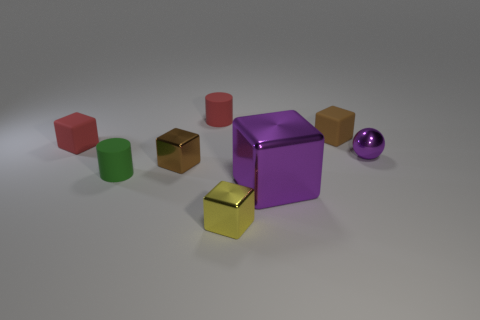How many objects are tiny green rubber cylinders or purple shiny blocks?
Keep it short and to the point. 2. There is a red cylinder; is it the same size as the metallic thing that is on the left side of the yellow cube?
Offer a very short reply. Yes. There is a matte cylinder that is in front of the brown thing that is behind the purple thing behind the large purple metal thing; what size is it?
Provide a succinct answer. Small. Are there any tiny brown matte cylinders?
Offer a very short reply. No. What number of balls have the same color as the big shiny object?
Keep it short and to the point. 1. What number of objects are tiny yellow metallic things in front of the tiny green thing or small cylinders in front of the purple metallic sphere?
Provide a succinct answer. 2. There is a purple metallic object that is on the right side of the purple shiny cube; what number of tiny purple objects are behind it?
Give a very brief answer. 0. There is another cylinder that is made of the same material as the green cylinder; what is its color?
Your response must be concise. Red. Are there any purple balls of the same size as the brown matte cube?
Give a very brief answer. Yes. What shape is the purple metal object that is the same size as the yellow thing?
Provide a short and direct response. Sphere. 